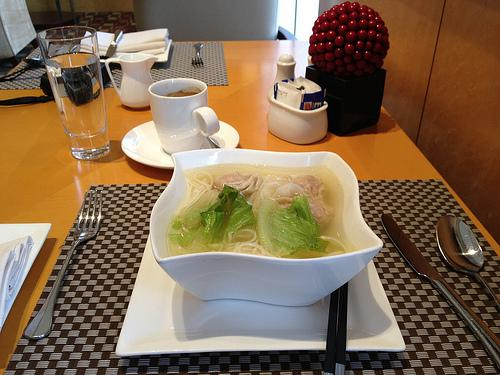Question: where are the knife and spoon?
Choices:
A. In drawer.
B. In sink.
C. To the right of the bowl.
D. In garbage.
Answer with the letter. Answer: C Question: where is the soup?
Choices:
A. In pot.
B. In the bowl.
C. On stove.
D. In microwave.
Answer with the letter. Answer: B Question: how many bowls of soup are there?
Choices:
A. Two.
B. Three.
C. One.
D. Four.
Answer with the letter. Answer: C Question: what pattern is the place mat?
Choices:
A. Checkers.
B. Floral.
C. Stripes.
D. Polka dots.
Answer with the letter. Answer: A 